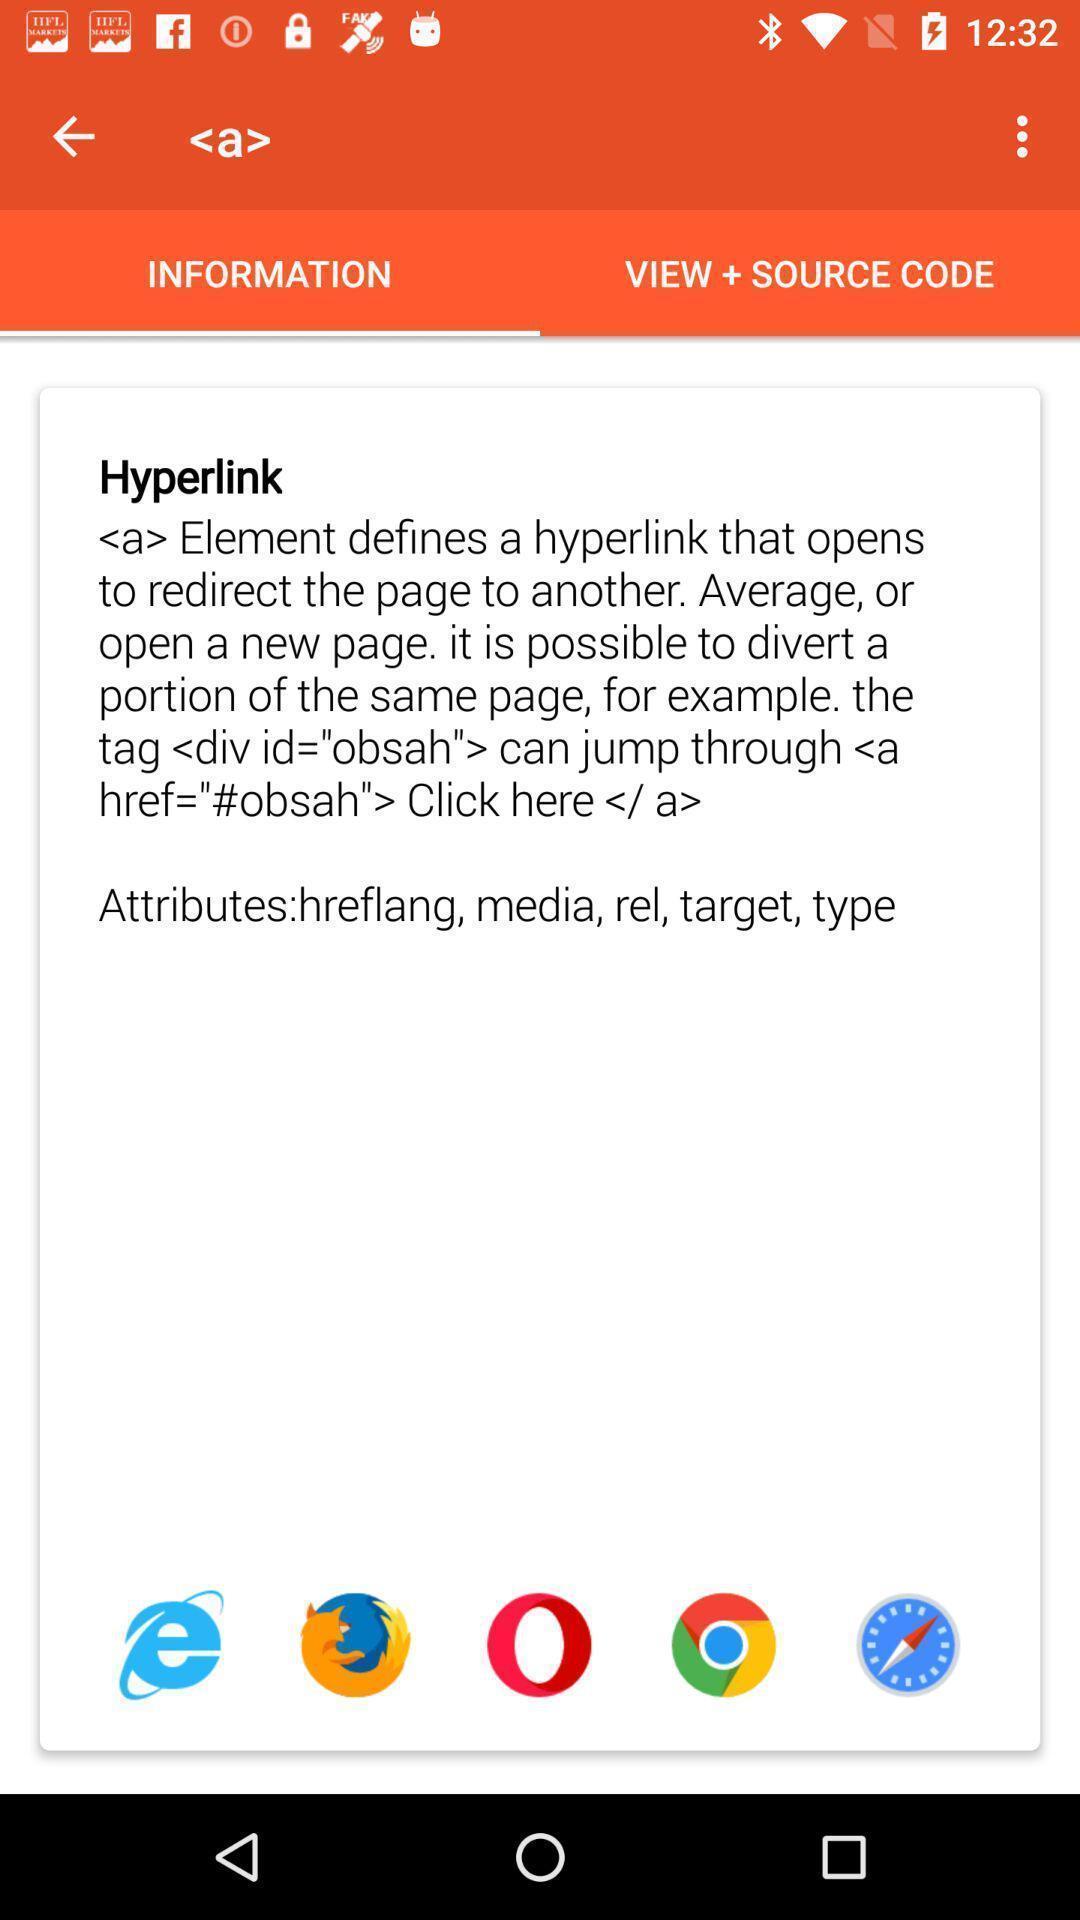What is the overall content of this screenshot? Screen displaying about the information about hyperlink. 